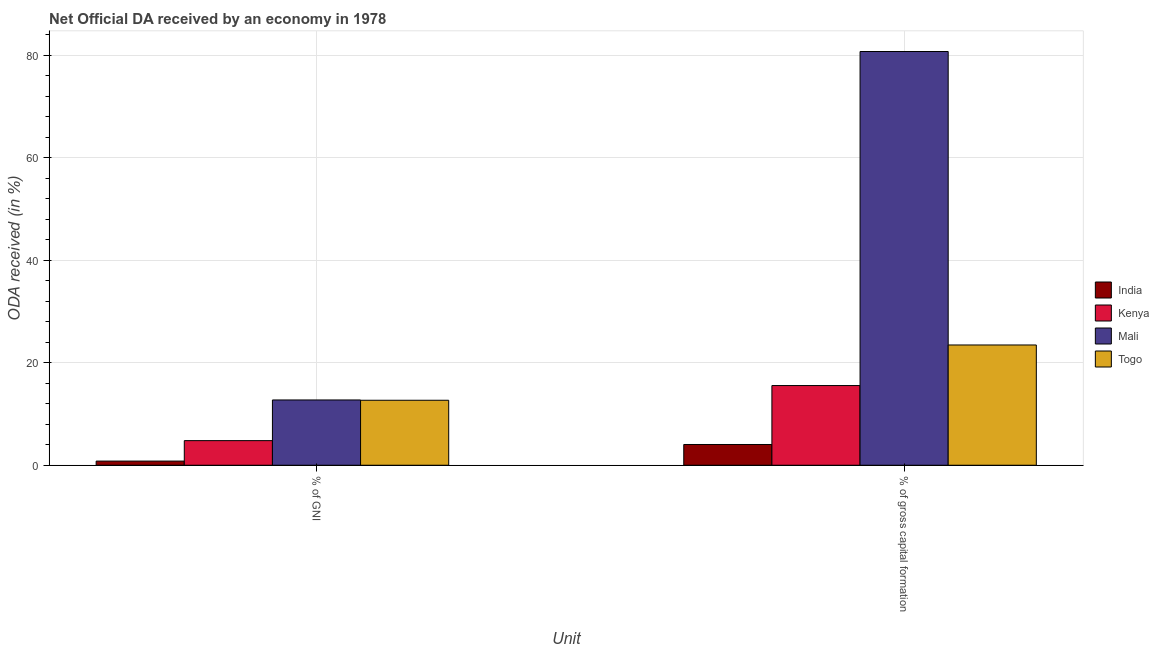How many different coloured bars are there?
Make the answer very short. 4. How many groups of bars are there?
Keep it short and to the point. 2. Are the number of bars per tick equal to the number of legend labels?
Your answer should be compact. Yes. Are the number of bars on each tick of the X-axis equal?
Your answer should be very brief. Yes. How many bars are there on the 1st tick from the right?
Keep it short and to the point. 4. What is the label of the 1st group of bars from the left?
Your answer should be very brief. % of GNI. What is the oda received as percentage of gni in India?
Ensure brevity in your answer.  0.81. Across all countries, what is the maximum oda received as percentage of gross capital formation?
Give a very brief answer. 80.71. Across all countries, what is the minimum oda received as percentage of gni?
Offer a very short reply. 0.81. In which country was the oda received as percentage of gross capital formation maximum?
Give a very brief answer. Mali. What is the total oda received as percentage of gross capital formation in the graph?
Provide a succinct answer. 123.76. What is the difference between the oda received as percentage of gross capital formation in Mali and that in Kenya?
Provide a succinct answer. 65.16. What is the difference between the oda received as percentage of gross capital formation in Togo and the oda received as percentage of gni in Kenya?
Your response must be concise. 18.66. What is the average oda received as percentage of gross capital formation per country?
Make the answer very short. 30.94. What is the difference between the oda received as percentage of gross capital formation and oda received as percentage of gni in Kenya?
Offer a terse response. 10.74. What is the ratio of the oda received as percentage of gross capital formation in Kenya to that in Togo?
Provide a succinct answer. 0.66. Is the oda received as percentage of gross capital formation in Kenya less than that in Togo?
Your answer should be very brief. Yes. In how many countries, is the oda received as percentage of gni greater than the average oda received as percentage of gni taken over all countries?
Your response must be concise. 2. What does the 2nd bar from the left in % of GNI represents?
Make the answer very short. Kenya. What does the 4th bar from the right in % of GNI represents?
Provide a succinct answer. India. How many bars are there?
Your answer should be compact. 8. What is the difference between two consecutive major ticks on the Y-axis?
Make the answer very short. 20. Where does the legend appear in the graph?
Provide a short and direct response. Center right. How many legend labels are there?
Offer a terse response. 4. What is the title of the graph?
Make the answer very short. Net Official DA received by an economy in 1978. What is the label or title of the X-axis?
Make the answer very short. Unit. What is the label or title of the Y-axis?
Your answer should be compact. ODA received (in %). What is the ODA received (in %) of India in % of GNI?
Give a very brief answer. 0.81. What is the ODA received (in %) of Kenya in % of GNI?
Ensure brevity in your answer.  4.8. What is the ODA received (in %) in Mali in % of GNI?
Make the answer very short. 12.73. What is the ODA received (in %) of Togo in % of GNI?
Your response must be concise. 12.68. What is the ODA received (in %) in India in % of gross capital formation?
Keep it short and to the point. 4.05. What is the ODA received (in %) of Kenya in % of gross capital formation?
Offer a terse response. 15.55. What is the ODA received (in %) of Mali in % of gross capital formation?
Offer a very short reply. 80.71. What is the ODA received (in %) in Togo in % of gross capital formation?
Ensure brevity in your answer.  23.46. Across all Unit, what is the maximum ODA received (in %) of India?
Offer a terse response. 4.05. Across all Unit, what is the maximum ODA received (in %) of Kenya?
Ensure brevity in your answer.  15.55. Across all Unit, what is the maximum ODA received (in %) of Mali?
Provide a short and direct response. 80.71. Across all Unit, what is the maximum ODA received (in %) in Togo?
Your answer should be very brief. 23.46. Across all Unit, what is the minimum ODA received (in %) in India?
Your answer should be very brief. 0.81. Across all Unit, what is the minimum ODA received (in %) of Kenya?
Offer a terse response. 4.8. Across all Unit, what is the minimum ODA received (in %) of Mali?
Ensure brevity in your answer.  12.73. Across all Unit, what is the minimum ODA received (in %) in Togo?
Your answer should be compact. 12.68. What is the total ODA received (in %) in India in the graph?
Keep it short and to the point. 4.86. What is the total ODA received (in %) in Kenya in the graph?
Offer a very short reply. 20.35. What is the total ODA received (in %) in Mali in the graph?
Keep it short and to the point. 93.44. What is the total ODA received (in %) in Togo in the graph?
Give a very brief answer. 36.14. What is the difference between the ODA received (in %) in India in % of GNI and that in % of gross capital formation?
Offer a terse response. -3.24. What is the difference between the ODA received (in %) in Kenya in % of GNI and that in % of gross capital formation?
Your answer should be compact. -10.74. What is the difference between the ODA received (in %) of Mali in % of GNI and that in % of gross capital formation?
Keep it short and to the point. -67.97. What is the difference between the ODA received (in %) in Togo in % of GNI and that in % of gross capital formation?
Your response must be concise. -10.79. What is the difference between the ODA received (in %) in India in % of GNI and the ODA received (in %) in Kenya in % of gross capital formation?
Your answer should be very brief. -14.73. What is the difference between the ODA received (in %) of India in % of GNI and the ODA received (in %) of Mali in % of gross capital formation?
Provide a short and direct response. -79.9. What is the difference between the ODA received (in %) of India in % of GNI and the ODA received (in %) of Togo in % of gross capital formation?
Ensure brevity in your answer.  -22.65. What is the difference between the ODA received (in %) of Kenya in % of GNI and the ODA received (in %) of Mali in % of gross capital formation?
Provide a succinct answer. -75.91. What is the difference between the ODA received (in %) in Kenya in % of GNI and the ODA received (in %) in Togo in % of gross capital formation?
Make the answer very short. -18.66. What is the difference between the ODA received (in %) of Mali in % of GNI and the ODA received (in %) of Togo in % of gross capital formation?
Provide a short and direct response. -10.73. What is the average ODA received (in %) of India per Unit?
Give a very brief answer. 2.43. What is the average ODA received (in %) in Kenya per Unit?
Offer a very short reply. 10.17. What is the average ODA received (in %) in Mali per Unit?
Keep it short and to the point. 46.72. What is the average ODA received (in %) in Togo per Unit?
Provide a short and direct response. 18.07. What is the difference between the ODA received (in %) of India and ODA received (in %) of Kenya in % of GNI?
Give a very brief answer. -3.99. What is the difference between the ODA received (in %) in India and ODA received (in %) in Mali in % of GNI?
Your answer should be compact. -11.92. What is the difference between the ODA received (in %) in India and ODA received (in %) in Togo in % of GNI?
Ensure brevity in your answer.  -11.86. What is the difference between the ODA received (in %) of Kenya and ODA received (in %) of Mali in % of GNI?
Give a very brief answer. -7.93. What is the difference between the ODA received (in %) of Kenya and ODA received (in %) of Togo in % of GNI?
Make the answer very short. -7.87. What is the difference between the ODA received (in %) of Mali and ODA received (in %) of Togo in % of GNI?
Give a very brief answer. 0.06. What is the difference between the ODA received (in %) of India and ODA received (in %) of Kenya in % of gross capital formation?
Your response must be concise. -11.5. What is the difference between the ODA received (in %) in India and ODA received (in %) in Mali in % of gross capital formation?
Provide a succinct answer. -76.66. What is the difference between the ODA received (in %) of India and ODA received (in %) of Togo in % of gross capital formation?
Your answer should be compact. -19.41. What is the difference between the ODA received (in %) in Kenya and ODA received (in %) in Mali in % of gross capital formation?
Offer a terse response. -65.16. What is the difference between the ODA received (in %) of Kenya and ODA received (in %) of Togo in % of gross capital formation?
Make the answer very short. -7.92. What is the difference between the ODA received (in %) in Mali and ODA received (in %) in Togo in % of gross capital formation?
Your response must be concise. 57.25. What is the ratio of the ODA received (in %) in India in % of GNI to that in % of gross capital formation?
Provide a short and direct response. 0.2. What is the ratio of the ODA received (in %) in Kenya in % of GNI to that in % of gross capital formation?
Ensure brevity in your answer.  0.31. What is the ratio of the ODA received (in %) of Mali in % of GNI to that in % of gross capital formation?
Make the answer very short. 0.16. What is the ratio of the ODA received (in %) of Togo in % of GNI to that in % of gross capital formation?
Your response must be concise. 0.54. What is the difference between the highest and the second highest ODA received (in %) of India?
Your answer should be very brief. 3.24. What is the difference between the highest and the second highest ODA received (in %) of Kenya?
Keep it short and to the point. 10.74. What is the difference between the highest and the second highest ODA received (in %) of Mali?
Give a very brief answer. 67.97. What is the difference between the highest and the second highest ODA received (in %) of Togo?
Give a very brief answer. 10.79. What is the difference between the highest and the lowest ODA received (in %) in India?
Make the answer very short. 3.24. What is the difference between the highest and the lowest ODA received (in %) of Kenya?
Provide a succinct answer. 10.74. What is the difference between the highest and the lowest ODA received (in %) of Mali?
Ensure brevity in your answer.  67.97. What is the difference between the highest and the lowest ODA received (in %) of Togo?
Provide a short and direct response. 10.79. 